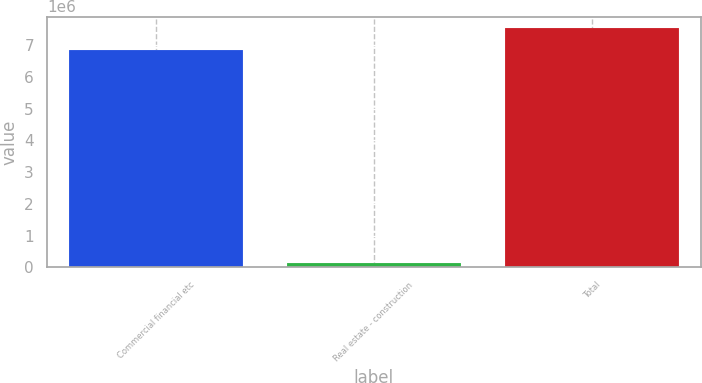Convert chart to OTSL. <chart><loc_0><loc_0><loc_500><loc_500><bar_chart><fcel>Commercial financial etc<fcel>Real estate - construction<fcel>Total<nl><fcel>6.84681e+06<fcel>128035<fcel>7.53149e+06<nl></chart> 